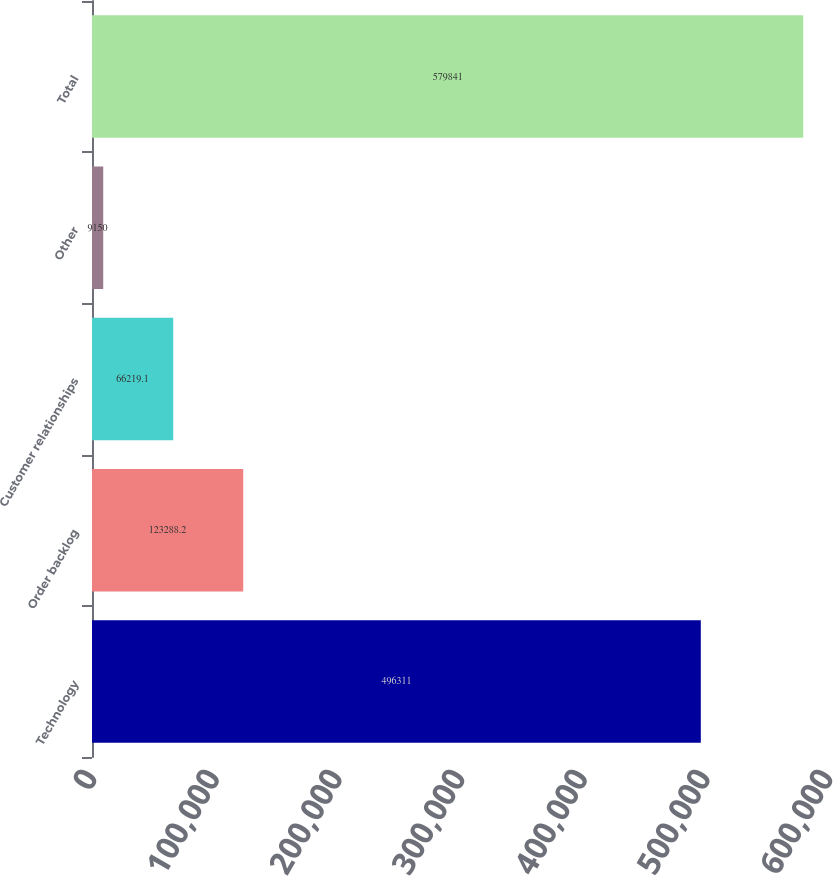Convert chart to OTSL. <chart><loc_0><loc_0><loc_500><loc_500><bar_chart><fcel>Technology<fcel>Order backlog<fcel>Customer relationships<fcel>Other<fcel>Total<nl><fcel>496311<fcel>123288<fcel>66219.1<fcel>9150<fcel>579841<nl></chart> 